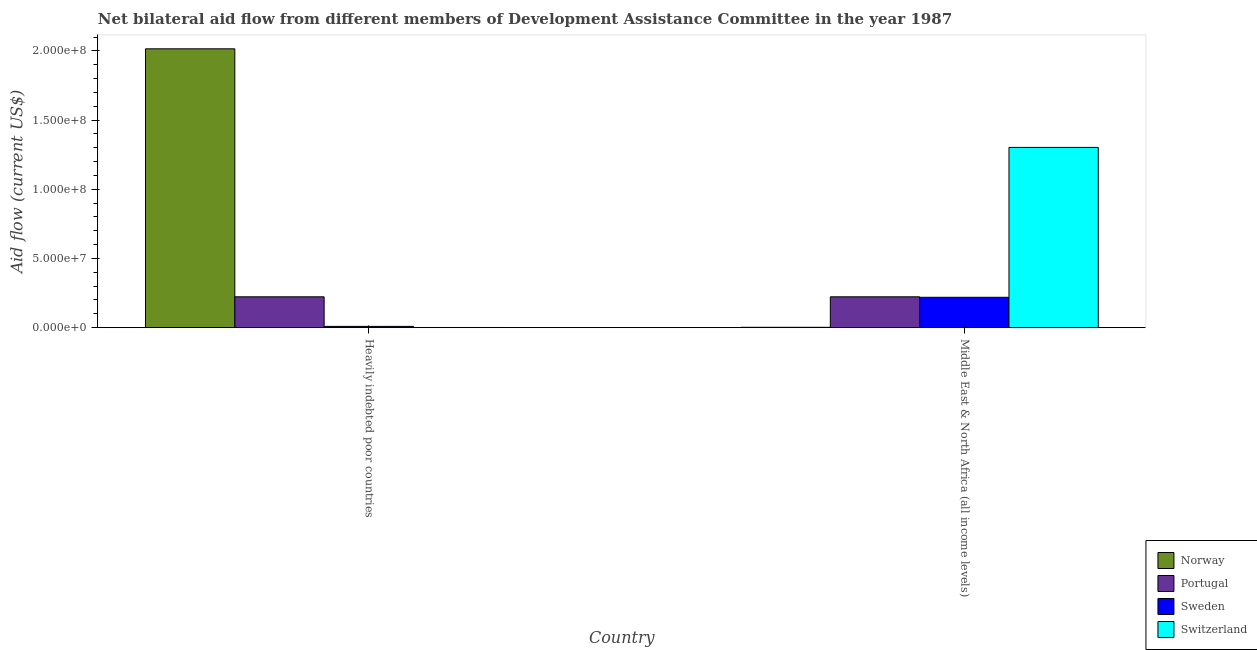How many groups of bars are there?
Provide a short and direct response. 2. Are the number of bars per tick equal to the number of legend labels?
Ensure brevity in your answer.  Yes. Are the number of bars on each tick of the X-axis equal?
Make the answer very short. Yes. What is the label of the 2nd group of bars from the left?
Provide a succinct answer. Middle East & North Africa (all income levels). In how many cases, is the number of bars for a given country not equal to the number of legend labels?
Give a very brief answer. 0. What is the amount of aid given by sweden in Middle East & North Africa (all income levels)?
Offer a very short reply. 2.20e+07. Across all countries, what is the maximum amount of aid given by switzerland?
Offer a very short reply. 1.30e+08. Across all countries, what is the minimum amount of aid given by norway?
Provide a succinct answer. 2.60e+05. In which country was the amount of aid given by sweden maximum?
Offer a very short reply. Middle East & North Africa (all income levels). In which country was the amount of aid given by sweden minimum?
Your answer should be very brief. Heavily indebted poor countries. What is the total amount of aid given by norway in the graph?
Offer a terse response. 2.02e+08. What is the difference between the amount of aid given by norway in Heavily indebted poor countries and that in Middle East & North Africa (all income levels)?
Give a very brief answer. 2.01e+08. What is the difference between the amount of aid given by sweden in Heavily indebted poor countries and the amount of aid given by portugal in Middle East & North Africa (all income levels)?
Ensure brevity in your answer.  -2.14e+07. What is the average amount of aid given by portugal per country?
Give a very brief answer. 2.23e+07. What is the difference between the amount of aid given by norway and amount of aid given by portugal in Heavily indebted poor countries?
Provide a short and direct response. 1.79e+08. In how many countries, is the amount of aid given by portugal greater than 110000000 US$?
Your answer should be very brief. 0. What is the ratio of the amount of aid given by norway in Heavily indebted poor countries to that in Middle East & North Africa (all income levels)?
Your answer should be compact. 775.19. Is the amount of aid given by switzerland in Heavily indebted poor countries less than that in Middle East & North Africa (all income levels)?
Your answer should be compact. Yes. In how many countries, is the amount of aid given by portugal greater than the average amount of aid given by portugal taken over all countries?
Ensure brevity in your answer.  0. Is it the case that in every country, the sum of the amount of aid given by sweden and amount of aid given by norway is greater than the sum of amount of aid given by portugal and amount of aid given by switzerland?
Your answer should be compact. No. What does the 2nd bar from the left in Middle East & North Africa (all income levels) represents?
Offer a terse response. Portugal. How many bars are there?
Provide a succinct answer. 8. Are all the bars in the graph horizontal?
Your answer should be very brief. No. Where does the legend appear in the graph?
Make the answer very short. Bottom right. How many legend labels are there?
Offer a very short reply. 4. What is the title of the graph?
Make the answer very short. Net bilateral aid flow from different members of Development Assistance Committee in the year 1987. Does "Compensation of employees" appear as one of the legend labels in the graph?
Make the answer very short. No. What is the label or title of the X-axis?
Your response must be concise. Country. What is the Aid flow (current US$) of Norway in Heavily indebted poor countries?
Keep it short and to the point. 2.02e+08. What is the Aid flow (current US$) in Portugal in Heavily indebted poor countries?
Your answer should be compact. 2.23e+07. What is the Aid flow (current US$) of Sweden in Heavily indebted poor countries?
Offer a very short reply. 9.20e+05. What is the Aid flow (current US$) of Norway in Middle East & North Africa (all income levels)?
Make the answer very short. 2.60e+05. What is the Aid flow (current US$) of Portugal in Middle East & North Africa (all income levels)?
Provide a short and direct response. 2.23e+07. What is the Aid flow (current US$) in Sweden in Middle East & North Africa (all income levels)?
Your answer should be very brief. 2.20e+07. What is the Aid flow (current US$) in Switzerland in Middle East & North Africa (all income levels)?
Keep it short and to the point. 1.30e+08. Across all countries, what is the maximum Aid flow (current US$) of Norway?
Ensure brevity in your answer.  2.02e+08. Across all countries, what is the maximum Aid flow (current US$) in Portugal?
Provide a succinct answer. 2.23e+07. Across all countries, what is the maximum Aid flow (current US$) of Sweden?
Ensure brevity in your answer.  2.20e+07. Across all countries, what is the maximum Aid flow (current US$) in Switzerland?
Keep it short and to the point. 1.30e+08. Across all countries, what is the minimum Aid flow (current US$) in Portugal?
Make the answer very short. 2.23e+07. Across all countries, what is the minimum Aid flow (current US$) in Sweden?
Ensure brevity in your answer.  9.20e+05. Across all countries, what is the minimum Aid flow (current US$) of Switzerland?
Provide a short and direct response. 1.20e+05. What is the total Aid flow (current US$) in Norway in the graph?
Your answer should be compact. 2.02e+08. What is the total Aid flow (current US$) in Portugal in the graph?
Your response must be concise. 4.46e+07. What is the total Aid flow (current US$) of Sweden in the graph?
Give a very brief answer. 2.29e+07. What is the total Aid flow (current US$) in Switzerland in the graph?
Your answer should be compact. 1.30e+08. What is the difference between the Aid flow (current US$) of Norway in Heavily indebted poor countries and that in Middle East & North Africa (all income levels)?
Ensure brevity in your answer.  2.01e+08. What is the difference between the Aid flow (current US$) of Portugal in Heavily indebted poor countries and that in Middle East & North Africa (all income levels)?
Provide a succinct answer. 0. What is the difference between the Aid flow (current US$) in Sweden in Heavily indebted poor countries and that in Middle East & North Africa (all income levels)?
Make the answer very short. -2.10e+07. What is the difference between the Aid flow (current US$) of Switzerland in Heavily indebted poor countries and that in Middle East & North Africa (all income levels)?
Your response must be concise. -1.30e+08. What is the difference between the Aid flow (current US$) of Norway in Heavily indebted poor countries and the Aid flow (current US$) of Portugal in Middle East & North Africa (all income levels)?
Offer a very short reply. 1.79e+08. What is the difference between the Aid flow (current US$) in Norway in Heavily indebted poor countries and the Aid flow (current US$) in Sweden in Middle East & North Africa (all income levels)?
Provide a succinct answer. 1.80e+08. What is the difference between the Aid flow (current US$) of Norway in Heavily indebted poor countries and the Aid flow (current US$) of Switzerland in Middle East & North Africa (all income levels)?
Your answer should be compact. 7.13e+07. What is the difference between the Aid flow (current US$) in Portugal in Heavily indebted poor countries and the Aid flow (current US$) in Sweden in Middle East & North Africa (all income levels)?
Offer a very short reply. 3.50e+05. What is the difference between the Aid flow (current US$) in Portugal in Heavily indebted poor countries and the Aid flow (current US$) in Switzerland in Middle East & North Africa (all income levels)?
Your answer should be very brief. -1.08e+08. What is the difference between the Aid flow (current US$) in Sweden in Heavily indebted poor countries and the Aid flow (current US$) in Switzerland in Middle East & North Africa (all income levels)?
Your answer should be compact. -1.29e+08. What is the average Aid flow (current US$) in Norway per country?
Give a very brief answer. 1.01e+08. What is the average Aid flow (current US$) in Portugal per country?
Your answer should be very brief. 2.23e+07. What is the average Aid flow (current US$) of Sweden per country?
Provide a succinct answer. 1.14e+07. What is the average Aid flow (current US$) in Switzerland per country?
Keep it short and to the point. 6.52e+07. What is the difference between the Aid flow (current US$) of Norway and Aid flow (current US$) of Portugal in Heavily indebted poor countries?
Provide a short and direct response. 1.79e+08. What is the difference between the Aid flow (current US$) of Norway and Aid flow (current US$) of Sweden in Heavily indebted poor countries?
Make the answer very short. 2.01e+08. What is the difference between the Aid flow (current US$) of Norway and Aid flow (current US$) of Switzerland in Heavily indebted poor countries?
Your answer should be very brief. 2.01e+08. What is the difference between the Aid flow (current US$) in Portugal and Aid flow (current US$) in Sweden in Heavily indebted poor countries?
Make the answer very short. 2.14e+07. What is the difference between the Aid flow (current US$) in Portugal and Aid flow (current US$) in Switzerland in Heavily indebted poor countries?
Offer a very short reply. 2.22e+07. What is the difference between the Aid flow (current US$) in Sweden and Aid flow (current US$) in Switzerland in Heavily indebted poor countries?
Your answer should be compact. 8.00e+05. What is the difference between the Aid flow (current US$) in Norway and Aid flow (current US$) in Portugal in Middle East & North Africa (all income levels)?
Keep it short and to the point. -2.20e+07. What is the difference between the Aid flow (current US$) in Norway and Aid flow (current US$) in Sweden in Middle East & North Africa (all income levels)?
Offer a very short reply. -2.17e+07. What is the difference between the Aid flow (current US$) in Norway and Aid flow (current US$) in Switzerland in Middle East & North Africa (all income levels)?
Your response must be concise. -1.30e+08. What is the difference between the Aid flow (current US$) in Portugal and Aid flow (current US$) in Switzerland in Middle East & North Africa (all income levels)?
Your answer should be compact. -1.08e+08. What is the difference between the Aid flow (current US$) of Sweden and Aid flow (current US$) of Switzerland in Middle East & North Africa (all income levels)?
Your answer should be very brief. -1.08e+08. What is the ratio of the Aid flow (current US$) of Norway in Heavily indebted poor countries to that in Middle East & North Africa (all income levels)?
Your response must be concise. 775.19. What is the ratio of the Aid flow (current US$) of Sweden in Heavily indebted poor countries to that in Middle East & North Africa (all income levels)?
Your answer should be very brief. 0.04. What is the ratio of the Aid flow (current US$) in Switzerland in Heavily indebted poor countries to that in Middle East & North Africa (all income levels)?
Keep it short and to the point. 0. What is the difference between the highest and the second highest Aid flow (current US$) of Norway?
Ensure brevity in your answer.  2.01e+08. What is the difference between the highest and the second highest Aid flow (current US$) of Sweden?
Make the answer very short. 2.10e+07. What is the difference between the highest and the second highest Aid flow (current US$) of Switzerland?
Your response must be concise. 1.30e+08. What is the difference between the highest and the lowest Aid flow (current US$) of Norway?
Provide a short and direct response. 2.01e+08. What is the difference between the highest and the lowest Aid flow (current US$) in Portugal?
Your response must be concise. 0. What is the difference between the highest and the lowest Aid flow (current US$) of Sweden?
Offer a very short reply. 2.10e+07. What is the difference between the highest and the lowest Aid flow (current US$) in Switzerland?
Make the answer very short. 1.30e+08. 